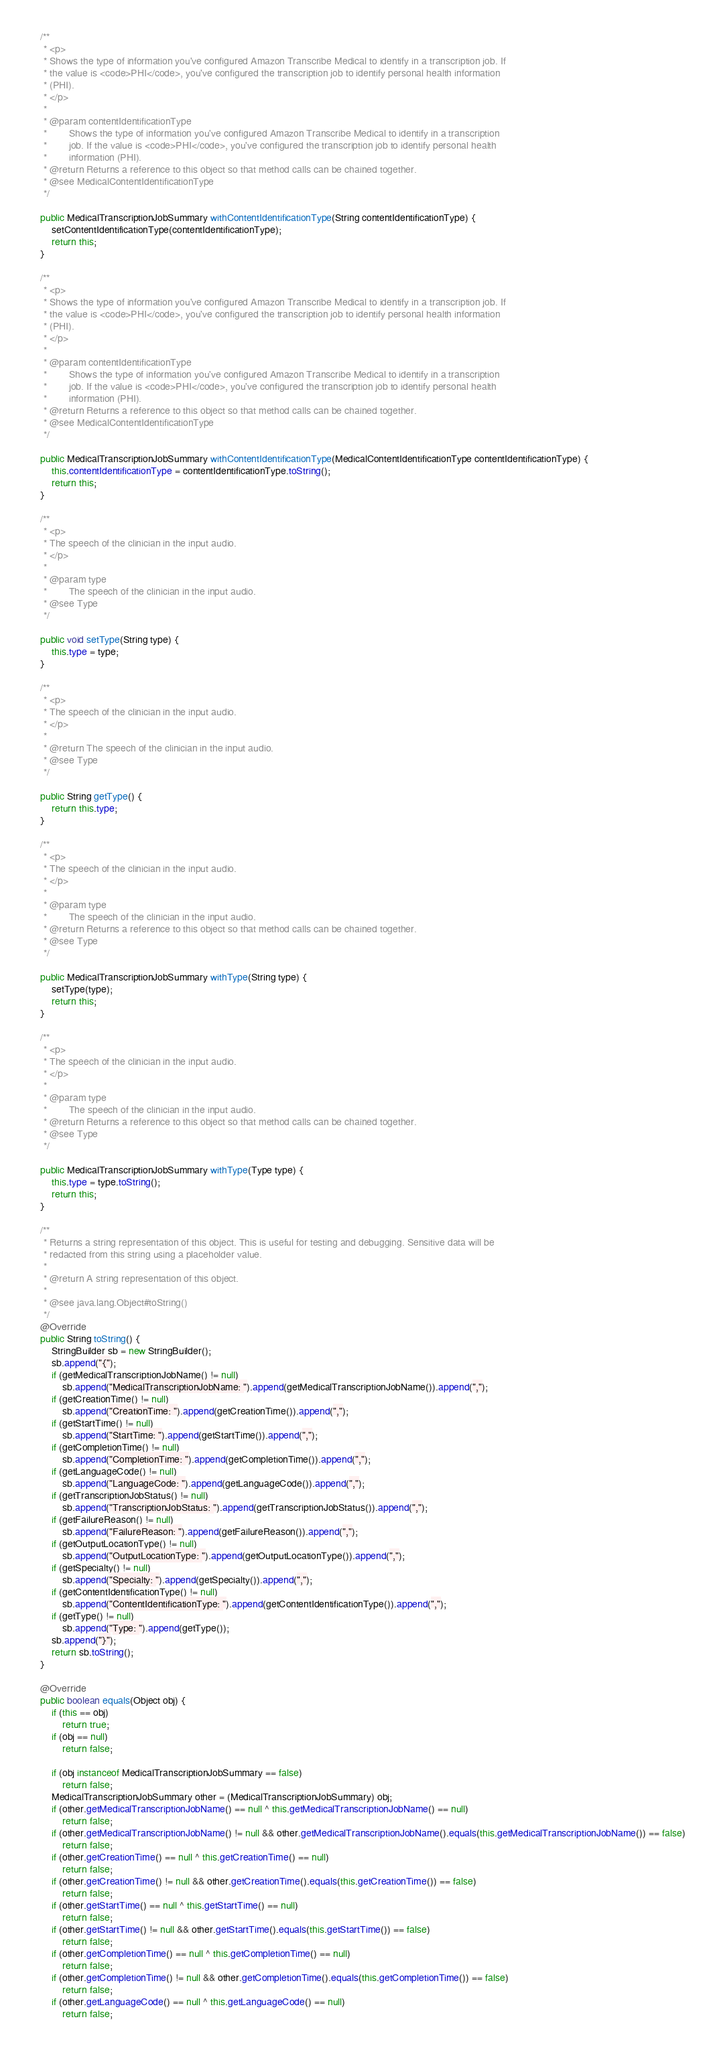Convert code to text. <code><loc_0><loc_0><loc_500><loc_500><_Java_>
    /**
     * <p>
     * Shows the type of information you've configured Amazon Transcribe Medical to identify in a transcription job. If
     * the value is <code>PHI</code>, you've configured the transcription job to identify personal health information
     * (PHI).
     * </p>
     * 
     * @param contentIdentificationType
     *        Shows the type of information you've configured Amazon Transcribe Medical to identify in a transcription
     *        job. If the value is <code>PHI</code>, you've configured the transcription job to identify personal health
     *        information (PHI).
     * @return Returns a reference to this object so that method calls can be chained together.
     * @see MedicalContentIdentificationType
     */

    public MedicalTranscriptionJobSummary withContentIdentificationType(String contentIdentificationType) {
        setContentIdentificationType(contentIdentificationType);
        return this;
    }

    /**
     * <p>
     * Shows the type of information you've configured Amazon Transcribe Medical to identify in a transcription job. If
     * the value is <code>PHI</code>, you've configured the transcription job to identify personal health information
     * (PHI).
     * </p>
     * 
     * @param contentIdentificationType
     *        Shows the type of information you've configured Amazon Transcribe Medical to identify in a transcription
     *        job. If the value is <code>PHI</code>, you've configured the transcription job to identify personal health
     *        information (PHI).
     * @return Returns a reference to this object so that method calls can be chained together.
     * @see MedicalContentIdentificationType
     */

    public MedicalTranscriptionJobSummary withContentIdentificationType(MedicalContentIdentificationType contentIdentificationType) {
        this.contentIdentificationType = contentIdentificationType.toString();
        return this;
    }

    /**
     * <p>
     * The speech of the clinician in the input audio.
     * </p>
     * 
     * @param type
     *        The speech of the clinician in the input audio.
     * @see Type
     */

    public void setType(String type) {
        this.type = type;
    }

    /**
     * <p>
     * The speech of the clinician in the input audio.
     * </p>
     * 
     * @return The speech of the clinician in the input audio.
     * @see Type
     */

    public String getType() {
        return this.type;
    }

    /**
     * <p>
     * The speech of the clinician in the input audio.
     * </p>
     * 
     * @param type
     *        The speech of the clinician in the input audio.
     * @return Returns a reference to this object so that method calls can be chained together.
     * @see Type
     */

    public MedicalTranscriptionJobSummary withType(String type) {
        setType(type);
        return this;
    }

    /**
     * <p>
     * The speech of the clinician in the input audio.
     * </p>
     * 
     * @param type
     *        The speech of the clinician in the input audio.
     * @return Returns a reference to this object so that method calls can be chained together.
     * @see Type
     */

    public MedicalTranscriptionJobSummary withType(Type type) {
        this.type = type.toString();
        return this;
    }

    /**
     * Returns a string representation of this object. This is useful for testing and debugging. Sensitive data will be
     * redacted from this string using a placeholder value.
     *
     * @return A string representation of this object.
     *
     * @see java.lang.Object#toString()
     */
    @Override
    public String toString() {
        StringBuilder sb = new StringBuilder();
        sb.append("{");
        if (getMedicalTranscriptionJobName() != null)
            sb.append("MedicalTranscriptionJobName: ").append(getMedicalTranscriptionJobName()).append(",");
        if (getCreationTime() != null)
            sb.append("CreationTime: ").append(getCreationTime()).append(",");
        if (getStartTime() != null)
            sb.append("StartTime: ").append(getStartTime()).append(",");
        if (getCompletionTime() != null)
            sb.append("CompletionTime: ").append(getCompletionTime()).append(",");
        if (getLanguageCode() != null)
            sb.append("LanguageCode: ").append(getLanguageCode()).append(",");
        if (getTranscriptionJobStatus() != null)
            sb.append("TranscriptionJobStatus: ").append(getTranscriptionJobStatus()).append(",");
        if (getFailureReason() != null)
            sb.append("FailureReason: ").append(getFailureReason()).append(",");
        if (getOutputLocationType() != null)
            sb.append("OutputLocationType: ").append(getOutputLocationType()).append(",");
        if (getSpecialty() != null)
            sb.append("Specialty: ").append(getSpecialty()).append(",");
        if (getContentIdentificationType() != null)
            sb.append("ContentIdentificationType: ").append(getContentIdentificationType()).append(",");
        if (getType() != null)
            sb.append("Type: ").append(getType());
        sb.append("}");
        return sb.toString();
    }

    @Override
    public boolean equals(Object obj) {
        if (this == obj)
            return true;
        if (obj == null)
            return false;

        if (obj instanceof MedicalTranscriptionJobSummary == false)
            return false;
        MedicalTranscriptionJobSummary other = (MedicalTranscriptionJobSummary) obj;
        if (other.getMedicalTranscriptionJobName() == null ^ this.getMedicalTranscriptionJobName() == null)
            return false;
        if (other.getMedicalTranscriptionJobName() != null && other.getMedicalTranscriptionJobName().equals(this.getMedicalTranscriptionJobName()) == false)
            return false;
        if (other.getCreationTime() == null ^ this.getCreationTime() == null)
            return false;
        if (other.getCreationTime() != null && other.getCreationTime().equals(this.getCreationTime()) == false)
            return false;
        if (other.getStartTime() == null ^ this.getStartTime() == null)
            return false;
        if (other.getStartTime() != null && other.getStartTime().equals(this.getStartTime()) == false)
            return false;
        if (other.getCompletionTime() == null ^ this.getCompletionTime() == null)
            return false;
        if (other.getCompletionTime() != null && other.getCompletionTime().equals(this.getCompletionTime()) == false)
            return false;
        if (other.getLanguageCode() == null ^ this.getLanguageCode() == null)
            return false;</code> 